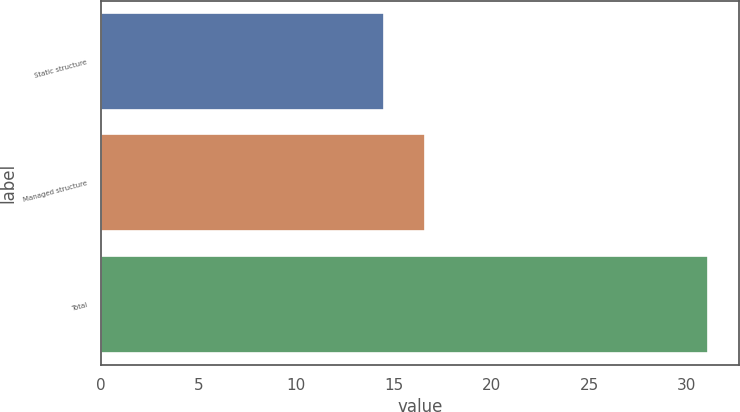<chart> <loc_0><loc_0><loc_500><loc_500><bar_chart><fcel>Static structure<fcel>Managed structure<fcel>Total<nl><fcel>14.5<fcel>16.6<fcel>31.1<nl></chart> 